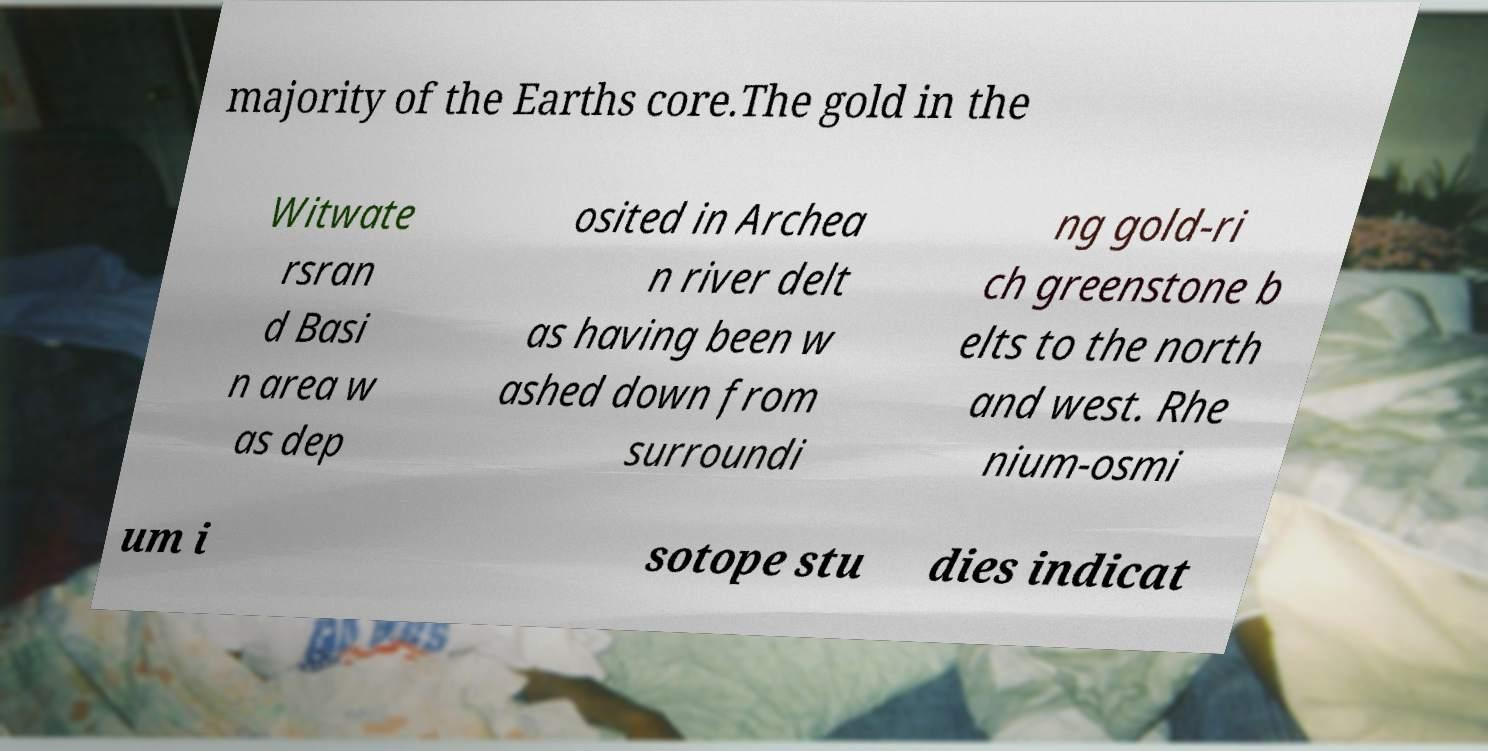Can you read and provide the text displayed in the image?This photo seems to have some interesting text. Can you extract and type it out for me? majority of the Earths core.The gold in the Witwate rsran d Basi n area w as dep osited in Archea n river delt as having been w ashed down from surroundi ng gold-ri ch greenstone b elts to the north and west. Rhe nium-osmi um i sotope stu dies indicat 